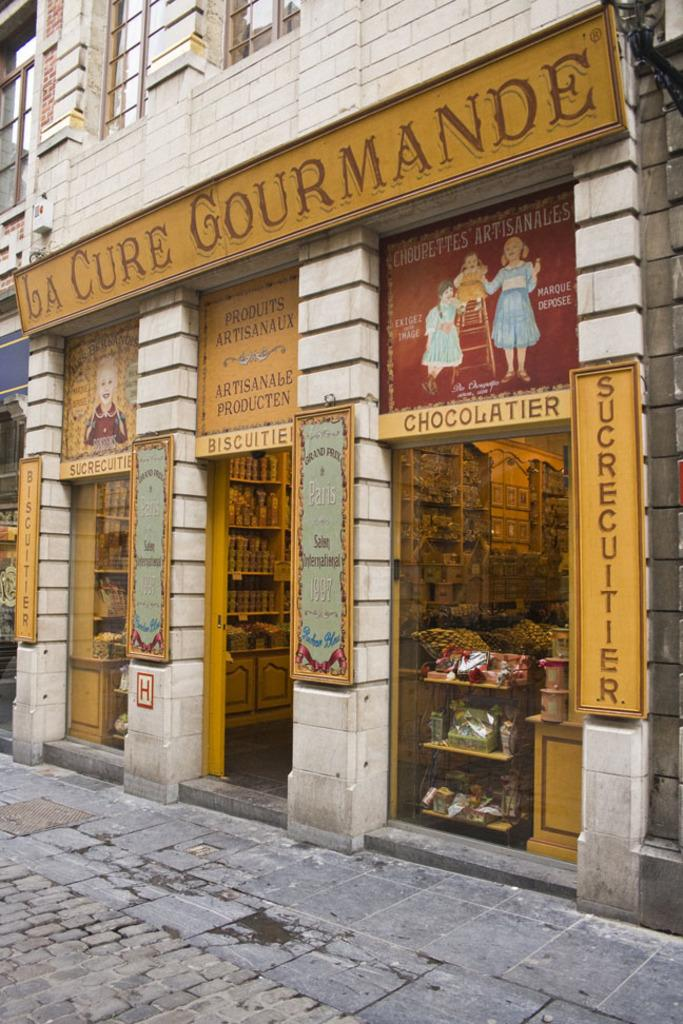What type of structure is present in the image? There is a building in the image. What can be seen on the building in the image? There are boards visible on the building in the image. What type of establishments can be seen in the building? There are stores visible in the image. What is the surface beneath the building in the image? The bottom of the image contains a floor. Can you see any fangs on the building in the image? There are no fangs present on the building in the image. What type of feathers can be seen on the cart in the image? There is no cart present in the image, so there are no feathers to be seen. 